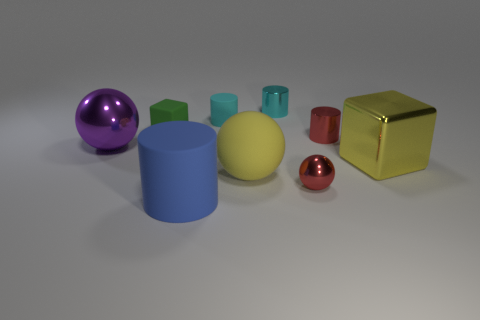Is the shape of the metallic thing that is left of the large yellow rubber sphere the same as the big yellow thing on the right side of the tiny red cylinder?
Make the answer very short. No. How many objects are either yellow cubes or yellow balls?
Your response must be concise. 2. What is the color of the metal block that is the same size as the blue rubber cylinder?
Provide a succinct answer. Yellow. There is a ball that is on the left side of the green cube; what number of things are behind it?
Provide a succinct answer. 4. What number of metal things are both behind the yellow cube and right of the green rubber cube?
Give a very brief answer. 2. What number of objects are shiny spheres that are right of the small green rubber block or rubber cylinders to the left of the tiny matte cylinder?
Offer a terse response. 2. What number of other things are the same size as the purple shiny ball?
Ensure brevity in your answer.  3. There is a yellow object that is to the left of the large shiny object that is right of the blue object; what shape is it?
Provide a succinct answer. Sphere. Is the color of the cylinder in front of the yellow rubber thing the same as the tiny metal cylinder in front of the small green matte cube?
Make the answer very short. No. Is there anything else of the same color as the large block?
Provide a short and direct response. Yes. 